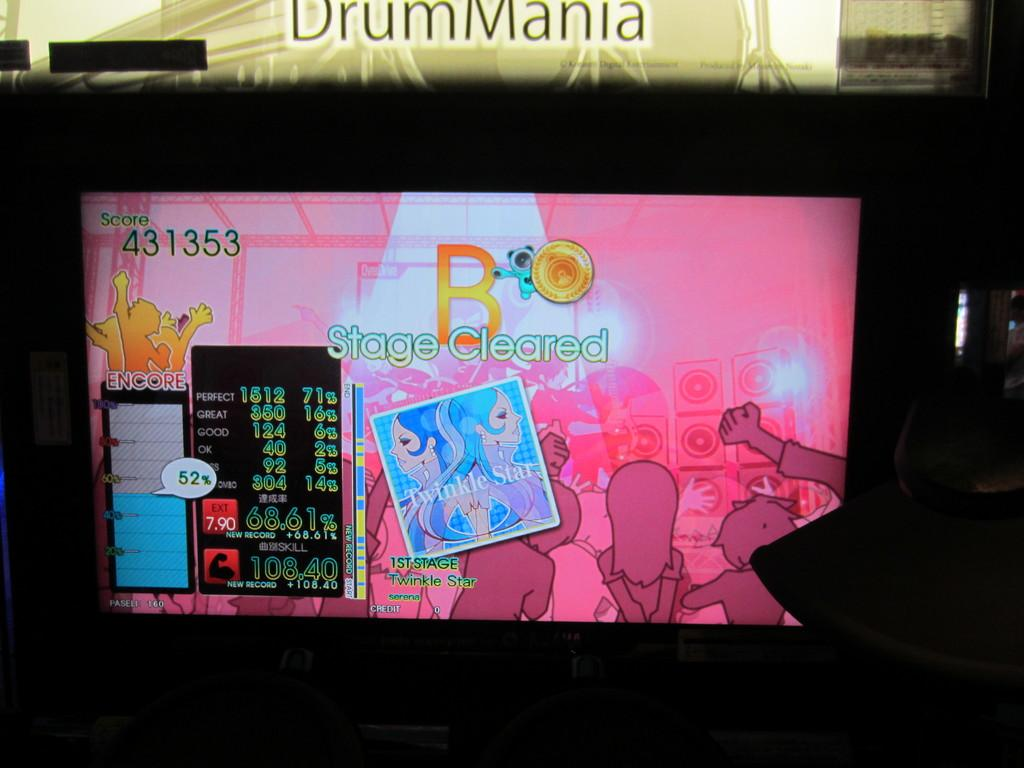<image>
Render a clear and concise summary of the photo. A game on the television with a stage cleared sign 